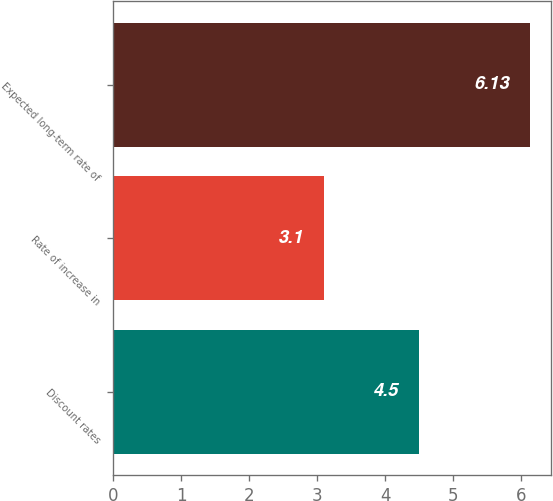<chart> <loc_0><loc_0><loc_500><loc_500><bar_chart><fcel>Discount rates<fcel>Rate of increase in<fcel>Expected long-term rate of<nl><fcel>4.5<fcel>3.1<fcel>6.13<nl></chart> 